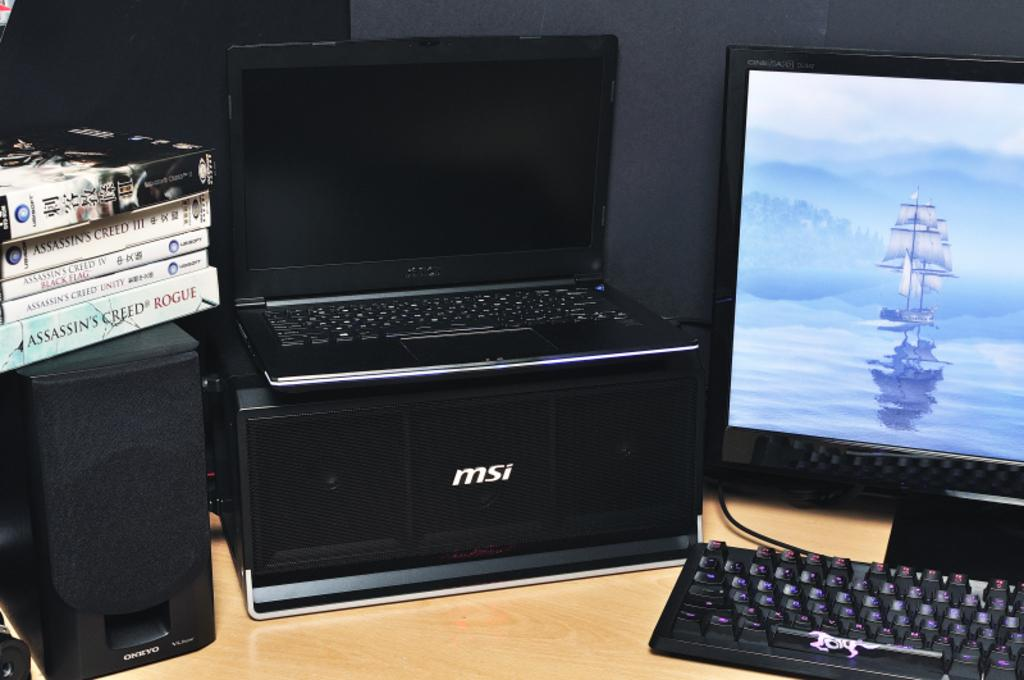<image>
Give a short and clear explanation of the subsequent image. Computer setup with MSI products and a stack of assassin creed games. 